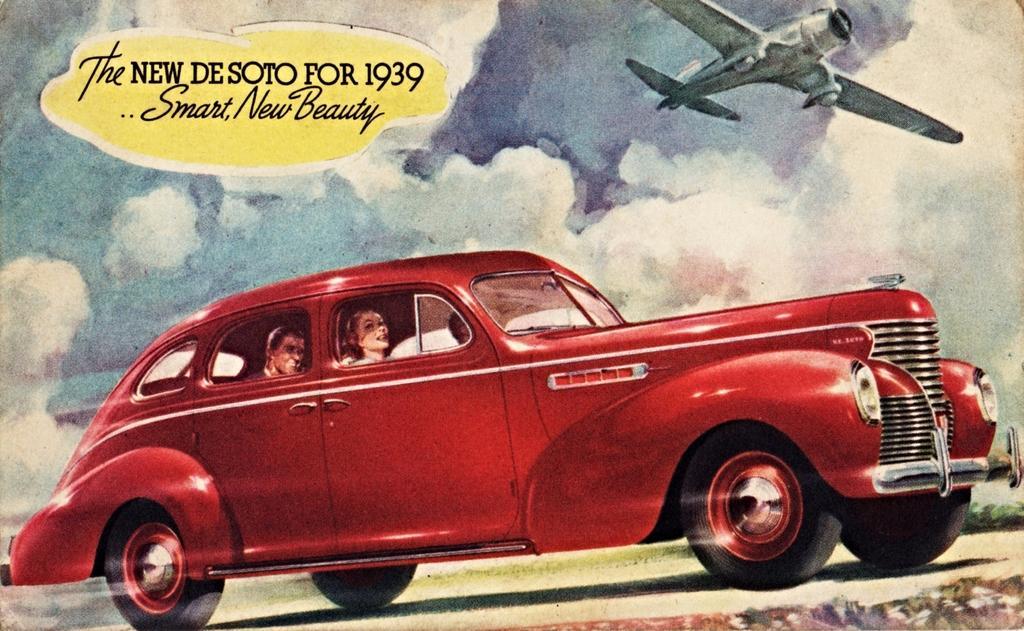Describe this image in one or two sentences. In this picture we can see a few people in a car. There is a text on the left side. We can see an aircraft in the sky. Sky is cloudy. 